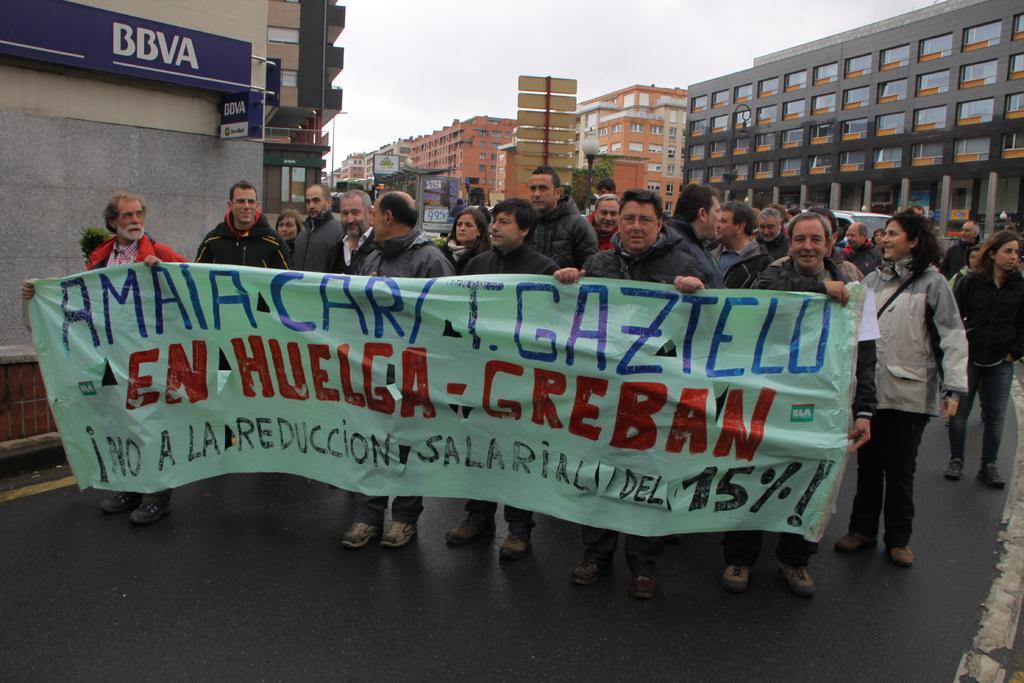How would you summarize this image in a sentence or two? In this image we can see a group of people standing and holding a banner, we can see some text on it, there are a few buildings and windows, we can see the road, vehicle, at the top we can see the sky. 